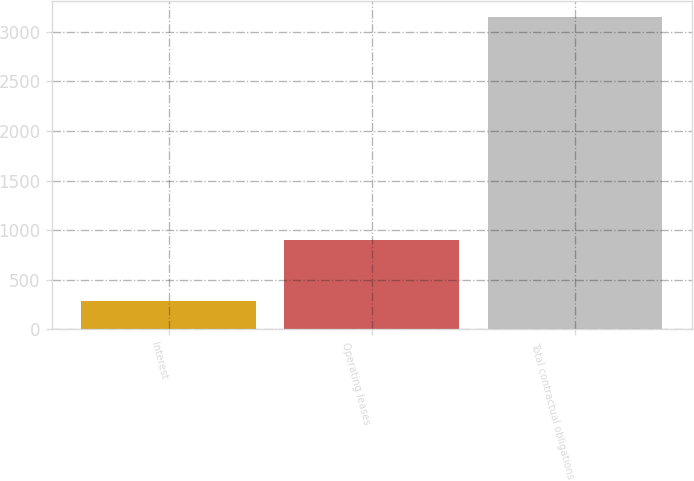<chart> <loc_0><loc_0><loc_500><loc_500><bar_chart><fcel>Interest<fcel>Operating leases<fcel>Total contractual obligations<nl><fcel>288<fcel>903<fcel>3151.3<nl></chart> 